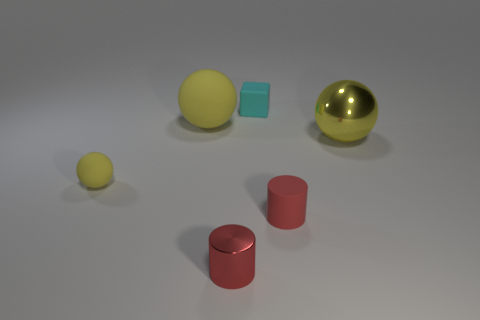Subtract all yellow spheres. How many were subtracted if there are1yellow spheres left? 2 Add 4 yellow rubber objects. How many objects exist? 10 Subtract all cylinders. How many objects are left? 4 Subtract 0 green spheres. How many objects are left? 6 Subtract all tiny things. Subtract all big purple rubber spheres. How many objects are left? 2 Add 3 red cylinders. How many red cylinders are left? 5 Add 2 large green cubes. How many large green cubes exist? 2 